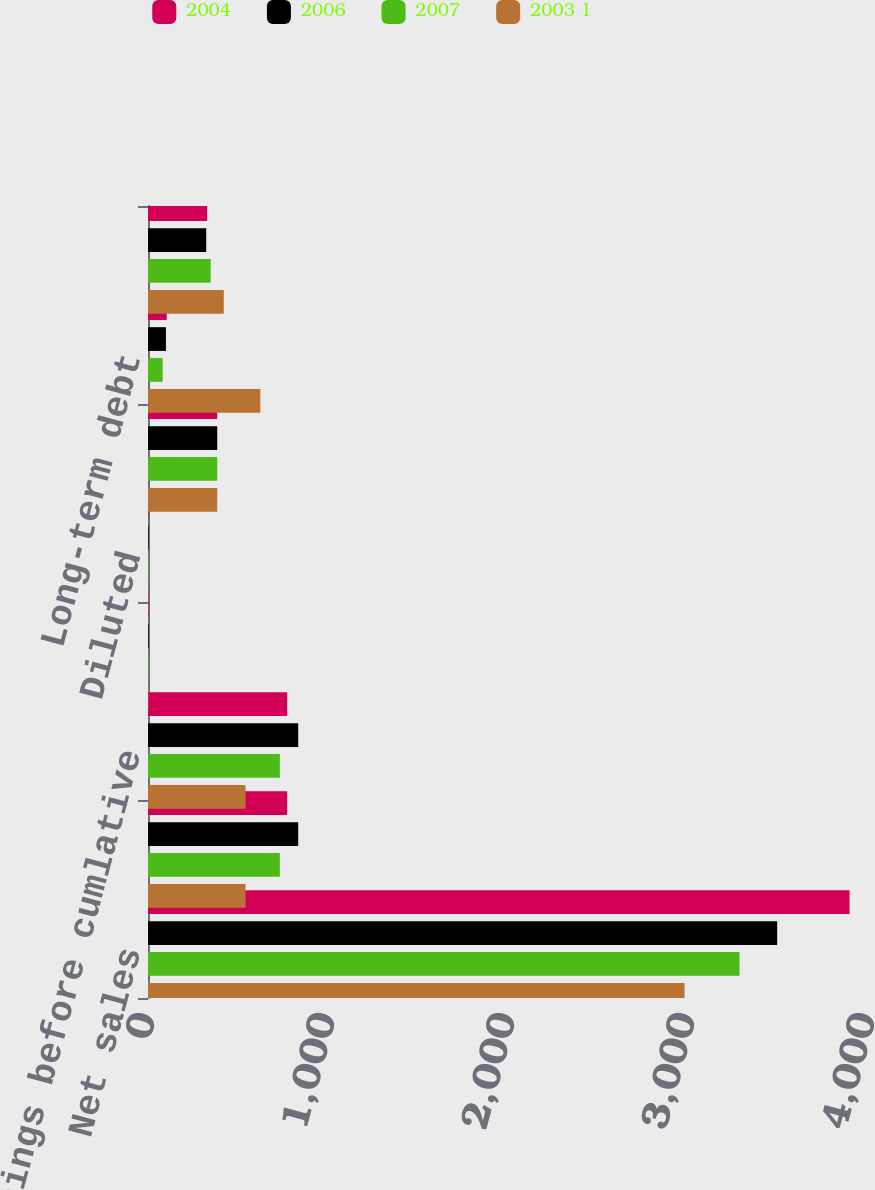<chart> <loc_0><loc_0><loc_500><loc_500><stacked_bar_chart><ecel><fcel>Net sales<fcel>Net earnings<fcel>Earnings before cumlative<fcel>Basic<fcel>Diluted<fcel>Total assets<fcel>Long-term debt<fcel>Other long-term obligations<nl><fcel>2004<fcel>3897.5<fcel>773.2<fcel>773.2<fcel>3.28<fcel>3.26<fcel>384.6<fcel>104.3<fcel>328.4<nl><fcel>2006<fcel>3495.4<fcel>834.5<fcel>834.5<fcel>3.43<fcel>3.4<fcel>384.6<fcel>99.6<fcel>323.4<nl><fcel>2007<fcel>3286.1<fcel>732.5<fcel>732.5<fcel>2.96<fcel>2.93<fcel>384.6<fcel>81.6<fcel>348.3<nl><fcel>2003 1<fcel>2980.9<fcel>541.8<fcel>541.8<fcel>2.22<fcel>2.19<fcel>384.6<fcel>624<fcel>420.9<nl></chart> 